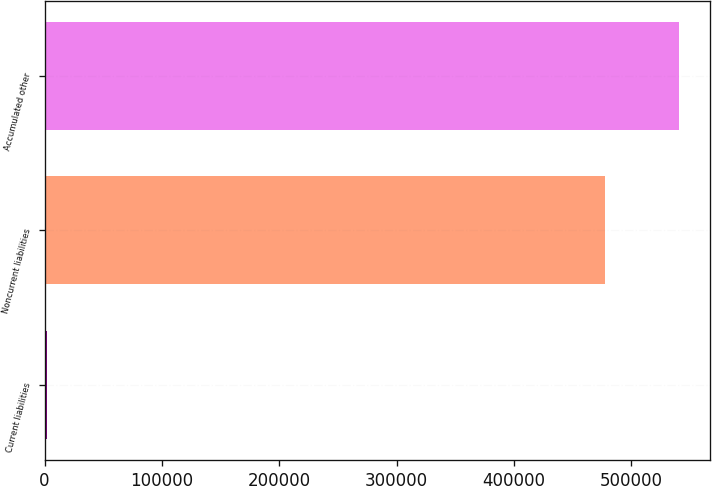Convert chart to OTSL. <chart><loc_0><loc_0><loc_500><loc_500><bar_chart><fcel>Current liabilities<fcel>Noncurrent liabilities<fcel>Accumulated other<nl><fcel>2411<fcel>477867<fcel>540588<nl></chart> 